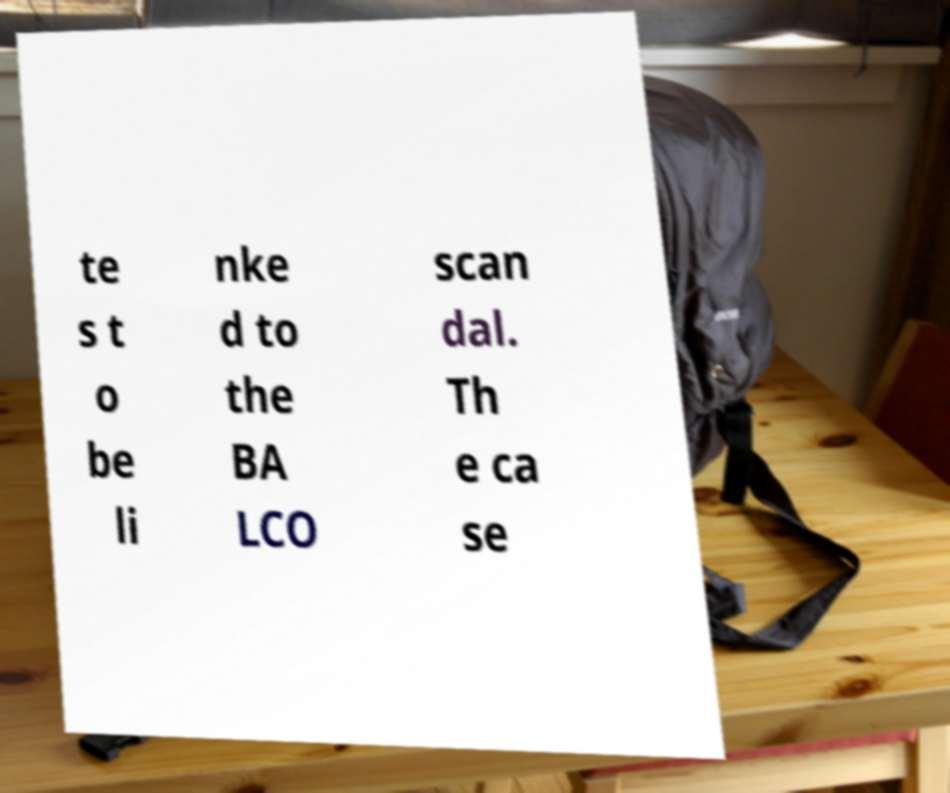Please read and relay the text visible in this image. What does it say? te s t o be li nke d to the BA LCO scan dal. Th e ca se 